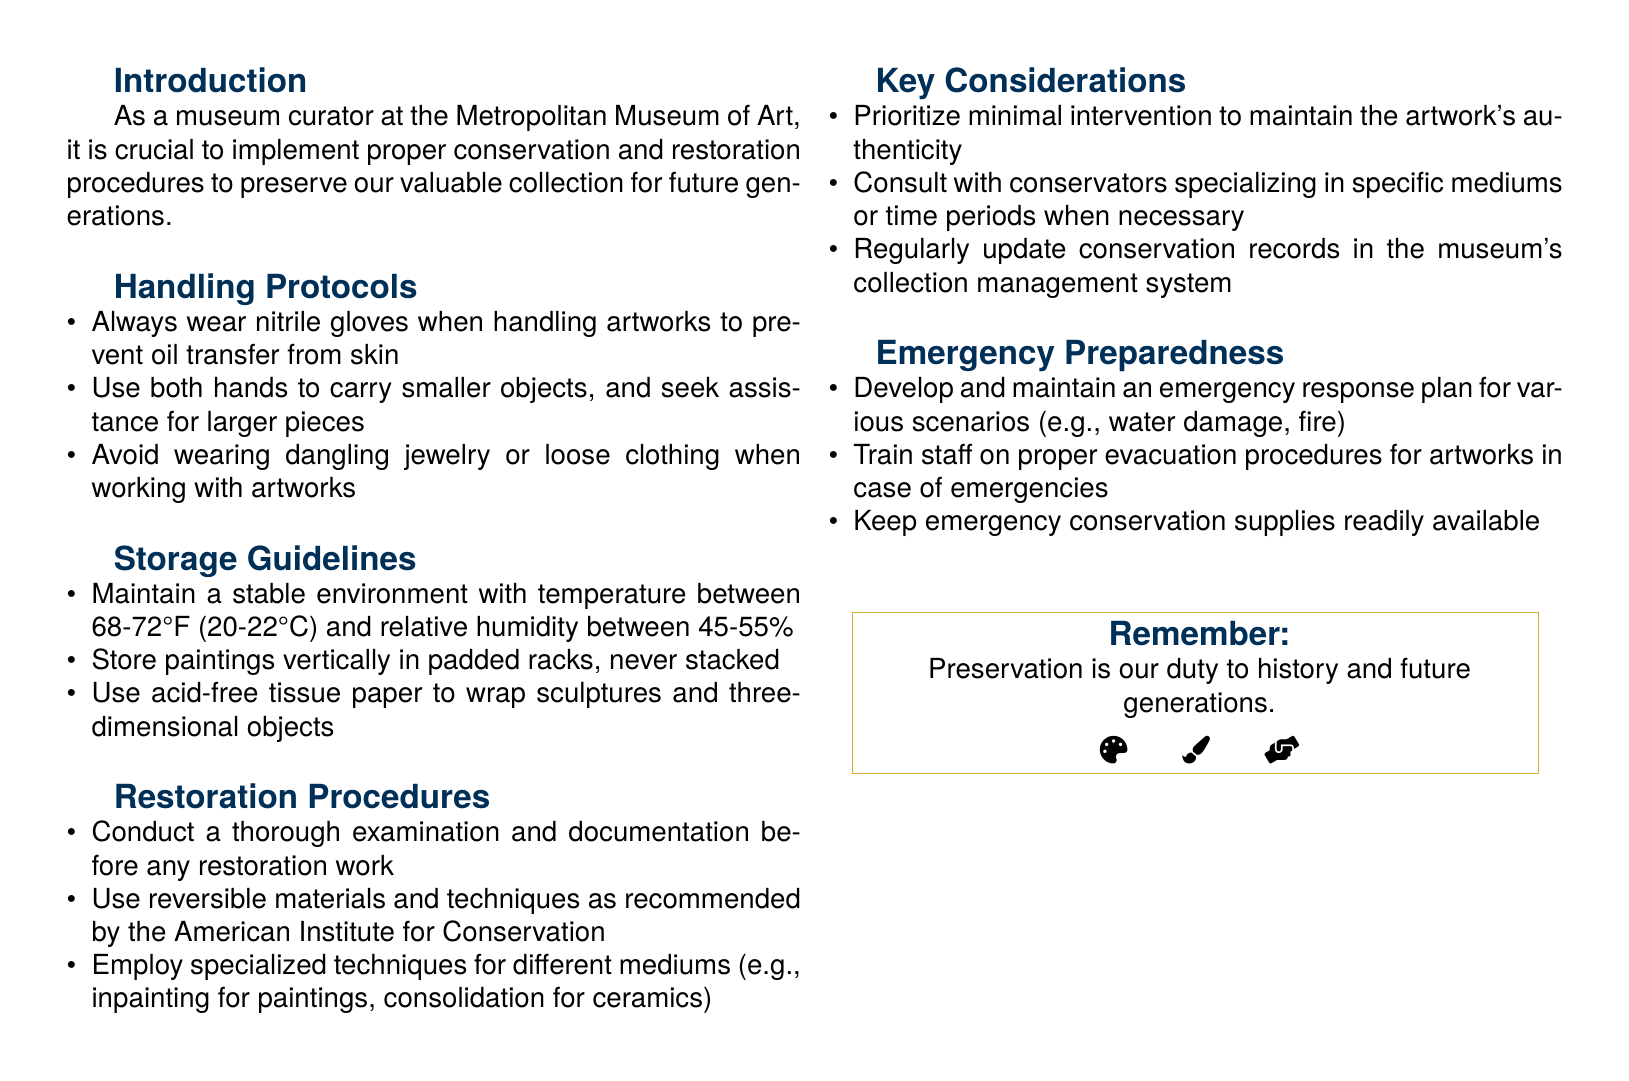What is the recommended temperature for storing artworks? The document specifies maintaining a stable environment with a temperature between 68-72°F (20-22°C).
Answer: 68-72°F (20-22°C) What material should be used to wrap sculptures? The document mentions using acid-free tissue paper to wrap sculptures and three-dimensional objects.
Answer: Acid-free tissue paper What is the purpose of wearing nitrile gloves? The document states that wearing nitrile gloves prevents oil transfer from skin when handling artworks.
Answer: Prevent oil transfer What should be prioritized during restoration? The document emphasizes prioritizing minimal intervention to maintain the artwork's authenticity.
Answer: Minimal intervention What type of materials should be used for restoration? According to the document, reversible materials and techniques as recommended by the American Institute for Conservation should be used.
Answer: Reversible materials How often should conservation records be updated? The document implies that conservation records should be regularly updated in the museum's collection management system.
Answer: Regularly What should staff be trained on according to emergency preparedness? The document mentions that staff should be trained on proper evacuation procedures for artworks in case of emergencies.
Answer: Evacuation procedures What is the title of this document? The title at the top of the document is "Artwork Conservation and Restoration Procedures."
Answer: Artwork Conservation and Restoration Procedures What is a key consideration when consulting regarding conservation? The document states that conservators specializing in specific mediums or time periods should be consulted when necessary.
Answer: Consult conservators 